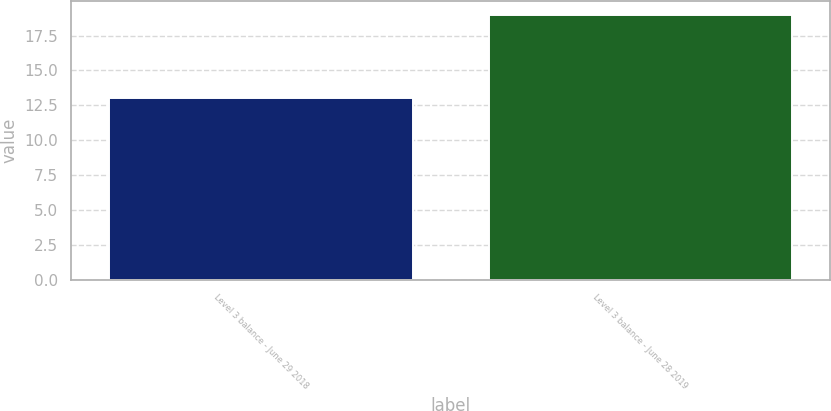<chart> <loc_0><loc_0><loc_500><loc_500><bar_chart><fcel>Level 3 balance - June 29 2018<fcel>Level 3 balance - June 28 2019<nl><fcel>13<fcel>19<nl></chart> 